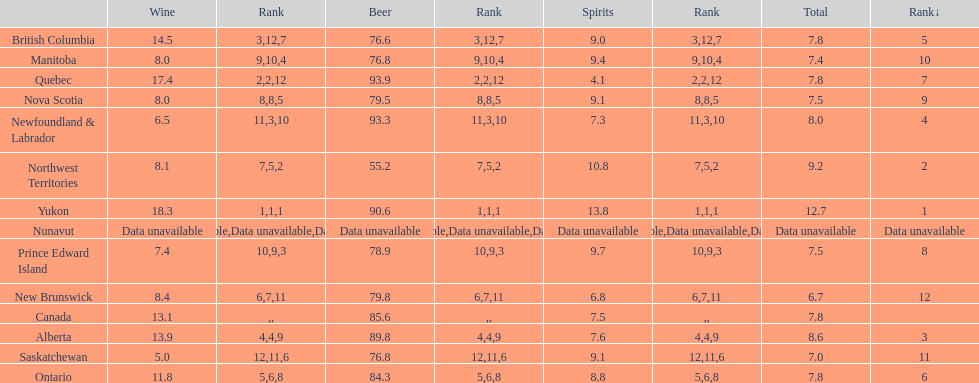Which province consumes the least amount of spirits? Quebec. 